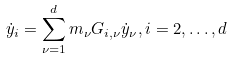Convert formula to latex. <formula><loc_0><loc_0><loc_500><loc_500>\dot { y } _ { i } = \sum _ { \nu = 1 } ^ { d } m _ { \nu } G _ { i , \nu } \dot { y } _ { \nu } , i = 2 , \dots , d</formula> 